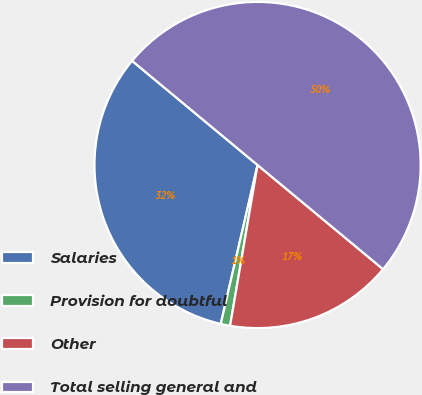<chart> <loc_0><loc_0><loc_500><loc_500><pie_chart><fcel>Salaries<fcel>Provision for doubtful<fcel>Other<fcel>Total selling general and<nl><fcel>32.41%<fcel>0.93%<fcel>16.67%<fcel>50.0%<nl></chart> 